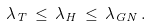Convert formula to latex. <formula><loc_0><loc_0><loc_500><loc_500>\lambda _ { T } \, \leq \, \lambda _ { H } \, \leq \, \lambda _ { G N } \, .</formula> 